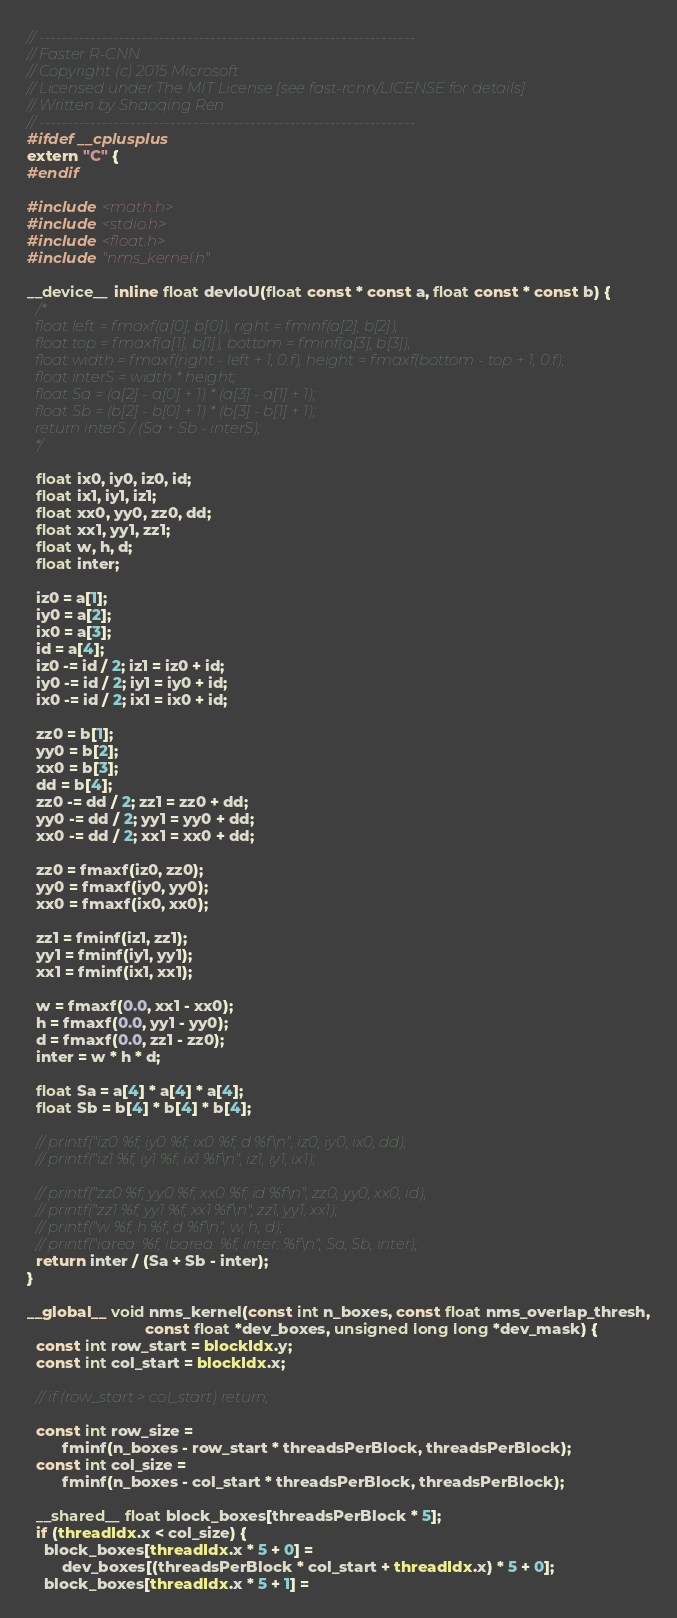<code> <loc_0><loc_0><loc_500><loc_500><_Cuda_>// ------------------------------------------------------------------
// Faster R-CNN
// Copyright (c) 2015 Microsoft
// Licensed under The MIT License [see fast-rcnn/LICENSE for details]
// Written by Shaoqing Ren
// ------------------------------------------------------------------
#ifdef __cplusplus
extern "C" {
#endif

#include <math.h>
#include <stdio.h>
#include <float.h>
#include "nms_kernel.h"

__device__ inline float devIoU(float const * const a, float const * const b) {
  /*
  float left = fmaxf(a[0], b[0]), right = fminf(a[2], b[2]);
  float top = fmaxf(a[1], b[1]), bottom = fminf(a[3], b[3]);
  float width = fmaxf(right - left + 1, 0.f), height = fmaxf(bottom - top + 1, 0.f);
  float interS = width * height;
  float Sa = (a[2] - a[0] + 1) * (a[3] - a[1] + 1);
  float Sb = (b[2] - b[0] + 1) * (b[3] - b[1] + 1);
  return interS / (Sa + Sb - interS);
  */

  float ix0, iy0, iz0, id;
  float ix1, iy1, iz1;
  float xx0, yy0, zz0, dd;
  float xx1, yy1, zz1;
  float w, h, d;
  float inter;

  iz0 = a[1];
  iy0 = a[2];
  ix0 = a[3];
  id = a[4];
  iz0 -= id / 2; iz1 = iz0 + id;
  iy0 -= id / 2; iy1 = iy0 + id;
  ix0 -= id / 2; ix1 = ix0 + id;

  zz0 = b[1];
  yy0 = b[2];
  xx0 = b[3];
  dd = b[4];
  zz0 -= dd / 2; zz1 = zz0 + dd;
  yy0 -= dd / 2; yy1 = yy0 + dd;
  xx0 -= dd / 2; xx1 = xx0 + dd;

  zz0 = fmaxf(iz0, zz0);
  yy0 = fmaxf(iy0, yy0);
  xx0 = fmaxf(ix0, xx0);

  zz1 = fminf(iz1, zz1);
  yy1 = fminf(iy1, yy1);
  xx1 = fminf(ix1, xx1);

  w = fmaxf(0.0, xx1 - xx0);
  h = fmaxf(0.0, yy1 - yy0);
  d = fmaxf(0.0, zz1 - zz0);
  inter = w * h * d;

  float Sa = a[4] * a[4] * a[4];
  float Sb = b[4] * b[4] * b[4];

  // printf("iz0 %f, iy0 %f, ix0 %f, d %f\n", iz0, iy0, ix0, dd);
  // printf("iz1 %f, iy1 %f, ix1 %f\n", iz1, iy1, ix1);

  // printf("zz0 %f, yy0 %f, xx0 %f, id %f\n", zz0, yy0, xx0, id);
  // printf("zz1 %f, yy1 %f, xx1 %f\n", zz1, yy1, xx1);
  // printf("w %f, h %f, d %f\n", w, h, d);
  // printf("iarea: %f, ibarea: %f, inter: %f\n", Sa, Sb, inter);
  return inter / (Sa + Sb - inter);
}

__global__ void nms_kernel(const int n_boxes, const float nms_overlap_thresh,
                           const float *dev_boxes, unsigned long long *dev_mask) {
  const int row_start = blockIdx.y;
  const int col_start = blockIdx.x;

  // if (row_start > col_start) return;

  const int row_size =
        fminf(n_boxes - row_start * threadsPerBlock, threadsPerBlock);
  const int col_size =
        fminf(n_boxes - col_start * threadsPerBlock, threadsPerBlock);

  __shared__ float block_boxes[threadsPerBlock * 5];
  if (threadIdx.x < col_size) {
    block_boxes[threadIdx.x * 5 + 0] =
        dev_boxes[(threadsPerBlock * col_start + threadIdx.x) * 5 + 0];
    block_boxes[threadIdx.x * 5 + 1] =</code> 